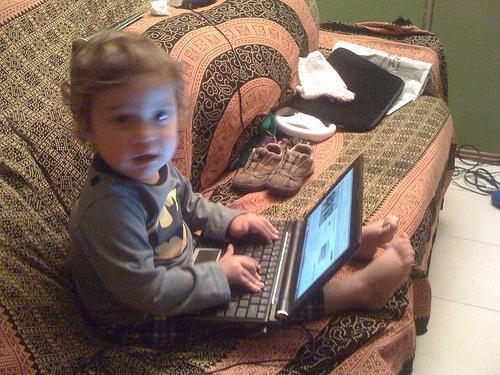How many children are there?
Give a very brief answer. 1. 